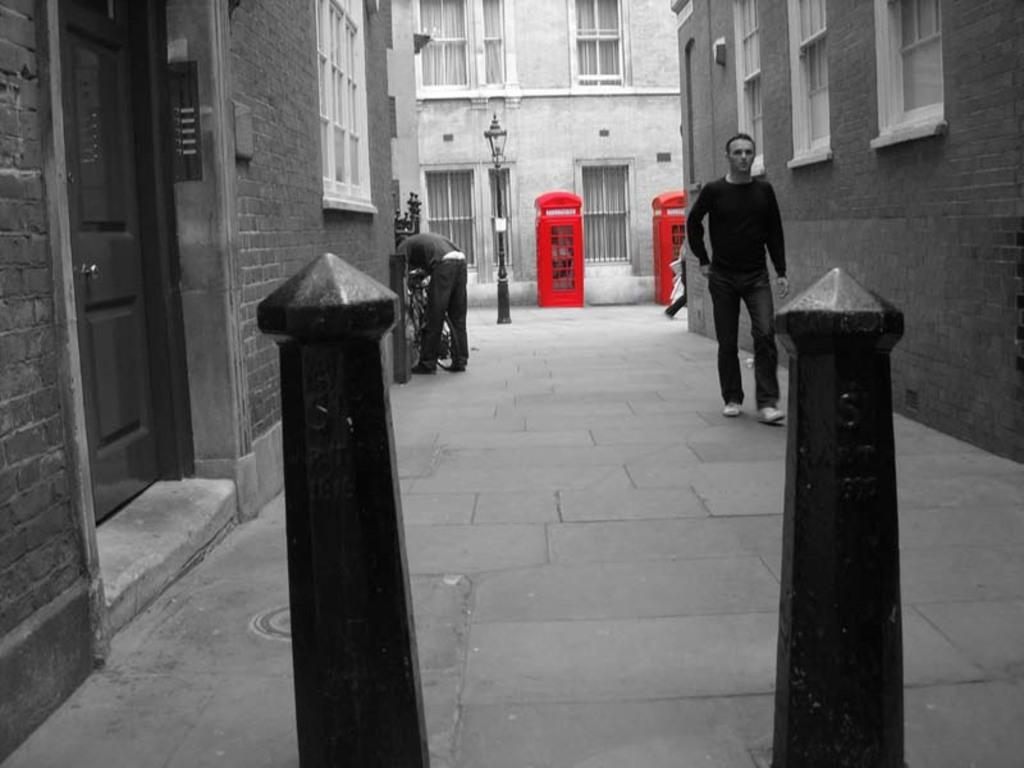How many people are in the image? There are two persons in the image. What can be seen in the image besides the people? There are metal rods in the image. What is visible in the background of the image? There are buildings, telephone booths, and a light pole in the background of the image. What type of manager can be seen interacting with the ducks in the image? There are no ducks or managers present in the image. 